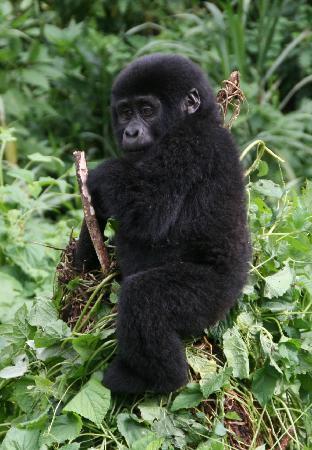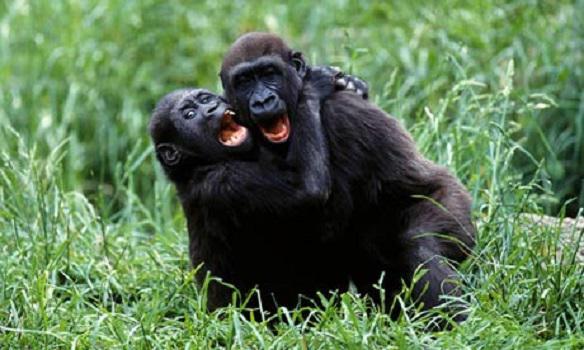The first image is the image on the left, the second image is the image on the right. Assess this claim about the two images: "The left image contains no more than one gorilla.". Correct or not? Answer yes or no. Yes. The first image is the image on the left, the second image is the image on the right. For the images shown, is this caption "One image shows two young gorillas playing on a tree branch, and one of them is climbing up the branch." true? Answer yes or no. No. 